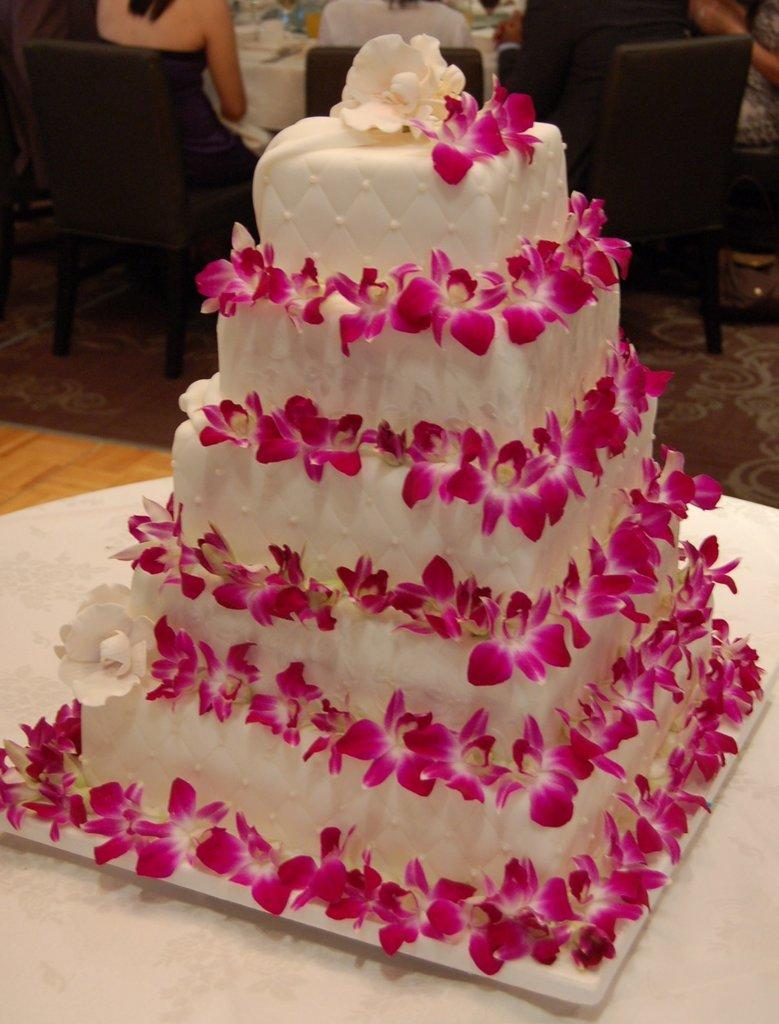In one or two sentences, can you explain what this image depicts? This image consist of a cake decorated with flowers is kept on a table. In the background, there are chairs and some people are sitting in the chairs. 